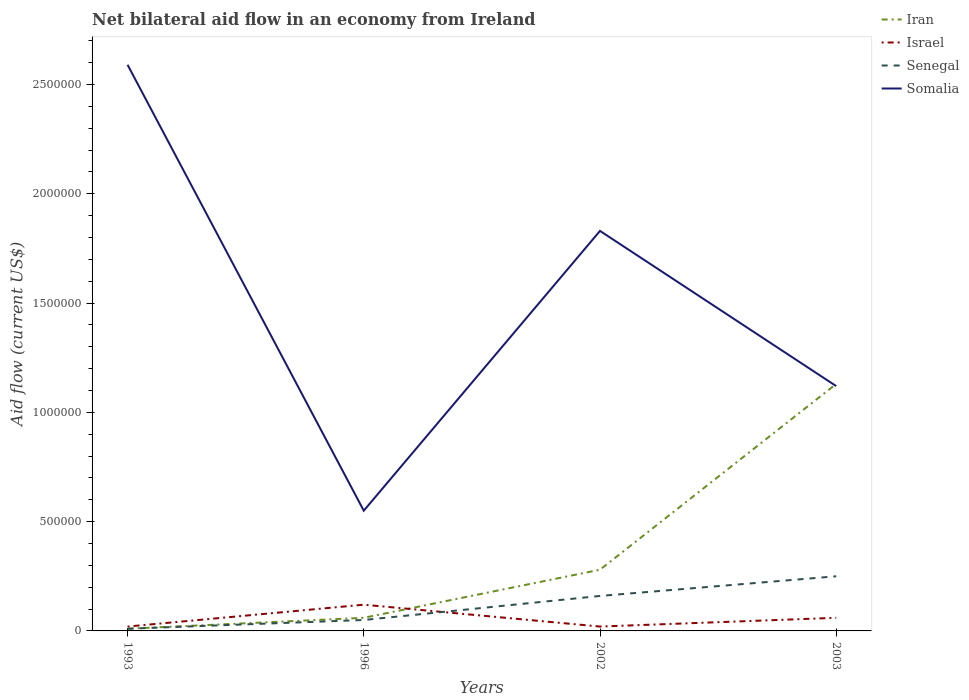In which year was the net bilateral aid flow in Somalia maximum?
Ensure brevity in your answer.  1996. What is the total net bilateral aid flow in Senegal in the graph?
Your answer should be compact. -2.00e+05. What is the difference between the highest and the second highest net bilateral aid flow in Somalia?
Give a very brief answer. 2.04e+06. Is the net bilateral aid flow in Senegal strictly greater than the net bilateral aid flow in Somalia over the years?
Ensure brevity in your answer.  Yes. How many lines are there?
Your answer should be very brief. 4. How many years are there in the graph?
Make the answer very short. 4. Does the graph contain any zero values?
Keep it short and to the point. No. Does the graph contain grids?
Ensure brevity in your answer.  No. What is the title of the graph?
Your answer should be very brief. Net bilateral aid flow in an economy from Ireland. Does "Finland" appear as one of the legend labels in the graph?
Your response must be concise. No. What is the Aid flow (current US$) in Iran in 1993?
Ensure brevity in your answer.  10000. What is the Aid flow (current US$) of Israel in 1993?
Ensure brevity in your answer.  2.00e+04. What is the Aid flow (current US$) in Senegal in 1993?
Keep it short and to the point. 10000. What is the Aid flow (current US$) in Somalia in 1993?
Your response must be concise. 2.59e+06. What is the Aid flow (current US$) in Iran in 1996?
Provide a succinct answer. 6.00e+04. What is the Aid flow (current US$) of Israel in 1996?
Provide a short and direct response. 1.20e+05. What is the Aid flow (current US$) of Israel in 2002?
Provide a succinct answer. 2.00e+04. What is the Aid flow (current US$) in Somalia in 2002?
Your answer should be very brief. 1.83e+06. What is the Aid flow (current US$) of Iran in 2003?
Ensure brevity in your answer.  1.13e+06. What is the Aid flow (current US$) of Israel in 2003?
Your answer should be compact. 6.00e+04. What is the Aid flow (current US$) in Somalia in 2003?
Ensure brevity in your answer.  1.12e+06. Across all years, what is the maximum Aid flow (current US$) of Iran?
Offer a terse response. 1.13e+06. Across all years, what is the maximum Aid flow (current US$) in Somalia?
Ensure brevity in your answer.  2.59e+06. Across all years, what is the minimum Aid flow (current US$) in Senegal?
Provide a short and direct response. 10000. What is the total Aid flow (current US$) of Iran in the graph?
Your response must be concise. 1.48e+06. What is the total Aid flow (current US$) in Israel in the graph?
Your answer should be very brief. 2.20e+05. What is the total Aid flow (current US$) in Somalia in the graph?
Make the answer very short. 6.09e+06. What is the difference between the Aid flow (current US$) of Iran in 1993 and that in 1996?
Offer a terse response. -5.00e+04. What is the difference between the Aid flow (current US$) of Israel in 1993 and that in 1996?
Give a very brief answer. -1.00e+05. What is the difference between the Aid flow (current US$) of Somalia in 1993 and that in 1996?
Make the answer very short. 2.04e+06. What is the difference between the Aid flow (current US$) in Iran in 1993 and that in 2002?
Offer a terse response. -2.70e+05. What is the difference between the Aid flow (current US$) in Israel in 1993 and that in 2002?
Keep it short and to the point. 0. What is the difference between the Aid flow (current US$) of Senegal in 1993 and that in 2002?
Offer a very short reply. -1.50e+05. What is the difference between the Aid flow (current US$) of Somalia in 1993 and that in 2002?
Give a very brief answer. 7.60e+05. What is the difference between the Aid flow (current US$) of Iran in 1993 and that in 2003?
Make the answer very short. -1.12e+06. What is the difference between the Aid flow (current US$) in Israel in 1993 and that in 2003?
Your response must be concise. -4.00e+04. What is the difference between the Aid flow (current US$) in Senegal in 1993 and that in 2003?
Offer a terse response. -2.40e+05. What is the difference between the Aid flow (current US$) in Somalia in 1993 and that in 2003?
Your response must be concise. 1.47e+06. What is the difference between the Aid flow (current US$) of Iran in 1996 and that in 2002?
Provide a succinct answer. -2.20e+05. What is the difference between the Aid flow (current US$) of Somalia in 1996 and that in 2002?
Offer a very short reply. -1.28e+06. What is the difference between the Aid flow (current US$) of Iran in 1996 and that in 2003?
Your response must be concise. -1.07e+06. What is the difference between the Aid flow (current US$) of Israel in 1996 and that in 2003?
Offer a terse response. 6.00e+04. What is the difference between the Aid flow (current US$) in Senegal in 1996 and that in 2003?
Give a very brief answer. -2.00e+05. What is the difference between the Aid flow (current US$) in Somalia in 1996 and that in 2003?
Provide a succinct answer. -5.70e+05. What is the difference between the Aid flow (current US$) in Iran in 2002 and that in 2003?
Offer a very short reply. -8.50e+05. What is the difference between the Aid flow (current US$) in Senegal in 2002 and that in 2003?
Provide a short and direct response. -9.00e+04. What is the difference between the Aid flow (current US$) of Somalia in 2002 and that in 2003?
Your answer should be very brief. 7.10e+05. What is the difference between the Aid flow (current US$) of Iran in 1993 and the Aid flow (current US$) of Somalia in 1996?
Provide a succinct answer. -5.40e+05. What is the difference between the Aid flow (current US$) of Israel in 1993 and the Aid flow (current US$) of Somalia in 1996?
Give a very brief answer. -5.30e+05. What is the difference between the Aid flow (current US$) in Senegal in 1993 and the Aid flow (current US$) in Somalia in 1996?
Give a very brief answer. -5.40e+05. What is the difference between the Aid flow (current US$) of Iran in 1993 and the Aid flow (current US$) of Israel in 2002?
Make the answer very short. -10000. What is the difference between the Aid flow (current US$) of Iran in 1993 and the Aid flow (current US$) of Senegal in 2002?
Offer a terse response. -1.50e+05. What is the difference between the Aid flow (current US$) of Iran in 1993 and the Aid flow (current US$) of Somalia in 2002?
Provide a short and direct response. -1.82e+06. What is the difference between the Aid flow (current US$) of Israel in 1993 and the Aid flow (current US$) of Somalia in 2002?
Provide a short and direct response. -1.81e+06. What is the difference between the Aid flow (current US$) of Senegal in 1993 and the Aid flow (current US$) of Somalia in 2002?
Offer a terse response. -1.82e+06. What is the difference between the Aid flow (current US$) in Iran in 1993 and the Aid flow (current US$) in Senegal in 2003?
Your answer should be very brief. -2.40e+05. What is the difference between the Aid flow (current US$) in Iran in 1993 and the Aid flow (current US$) in Somalia in 2003?
Make the answer very short. -1.11e+06. What is the difference between the Aid flow (current US$) of Israel in 1993 and the Aid flow (current US$) of Somalia in 2003?
Make the answer very short. -1.10e+06. What is the difference between the Aid flow (current US$) in Senegal in 1993 and the Aid flow (current US$) in Somalia in 2003?
Your answer should be very brief. -1.11e+06. What is the difference between the Aid flow (current US$) in Iran in 1996 and the Aid flow (current US$) in Senegal in 2002?
Your answer should be compact. -1.00e+05. What is the difference between the Aid flow (current US$) in Iran in 1996 and the Aid flow (current US$) in Somalia in 2002?
Your response must be concise. -1.77e+06. What is the difference between the Aid flow (current US$) of Israel in 1996 and the Aid flow (current US$) of Senegal in 2002?
Offer a terse response. -4.00e+04. What is the difference between the Aid flow (current US$) in Israel in 1996 and the Aid flow (current US$) in Somalia in 2002?
Provide a short and direct response. -1.71e+06. What is the difference between the Aid flow (current US$) in Senegal in 1996 and the Aid flow (current US$) in Somalia in 2002?
Give a very brief answer. -1.78e+06. What is the difference between the Aid flow (current US$) in Iran in 1996 and the Aid flow (current US$) in Somalia in 2003?
Your answer should be very brief. -1.06e+06. What is the difference between the Aid flow (current US$) of Senegal in 1996 and the Aid flow (current US$) of Somalia in 2003?
Ensure brevity in your answer.  -1.07e+06. What is the difference between the Aid flow (current US$) in Iran in 2002 and the Aid flow (current US$) in Somalia in 2003?
Provide a succinct answer. -8.40e+05. What is the difference between the Aid flow (current US$) in Israel in 2002 and the Aid flow (current US$) in Senegal in 2003?
Provide a short and direct response. -2.30e+05. What is the difference between the Aid flow (current US$) in Israel in 2002 and the Aid flow (current US$) in Somalia in 2003?
Your response must be concise. -1.10e+06. What is the difference between the Aid flow (current US$) of Senegal in 2002 and the Aid flow (current US$) of Somalia in 2003?
Your response must be concise. -9.60e+05. What is the average Aid flow (current US$) in Israel per year?
Your answer should be compact. 5.50e+04. What is the average Aid flow (current US$) in Senegal per year?
Your answer should be compact. 1.18e+05. What is the average Aid flow (current US$) of Somalia per year?
Ensure brevity in your answer.  1.52e+06. In the year 1993, what is the difference between the Aid flow (current US$) of Iran and Aid flow (current US$) of Somalia?
Make the answer very short. -2.58e+06. In the year 1993, what is the difference between the Aid flow (current US$) in Israel and Aid flow (current US$) in Senegal?
Your answer should be very brief. 10000. In the year 1993, what is the difference between the Aid flow (current US$) of Israel and Aid flow (current US$) of Somalia?
Offer a very short reply. -2.57e+06. In the year 1993, what is the difference between the Aid flow (current US$) in Senegal and Aid flow (current US$) in Somalia?
Your response must be concise. -2.58e+06. In the year 1996, what is the difference between the Aid flow (current US$) in Iran and Aid flow (current US$) in Senegal?
Provide a succinct answer. 10000. In the year 1996, what is the difference between the Aid flow (current US$) in Iran and Aid flow (current US$) in Somalia?
Your answer should be very brief. -4.90e+05. In the year 1996, what is the difference between the Aid flow (current US$) in Israel and Aid flow (current US$) in Senegal?
Provide a succinct answer. 7.00e+04. In the year 1996, what is the difference between the Aid flow (current US$) of Israel and Aid flow (current US$) of Somalia?
Provide a short and direct response. -4.30e+05. In the year 1996, what is the difference between the Aid flow (current US$) of Senegal and Aid flow (current US$) of Somalia?
Keep it short and to the point. -5.00e+05. In the year 2002, what is the difference between the Aid flow (current US$) in Iran and Aid flow (current US$) in Senegal?
Your response must be concise. 1.20e+05. In the year 2002, what is the difference between the Aid flow (current US$) of Iran and Aid flow (current US$) of Somalia?
Provide a short and direct response. -1.55e+06. In the year 2002, what is the difference between the Aid flow (current US$) of Israel and Aid flow (current US$) of Somalia?
Give a very brief answer. -1.81e+06. In the year 2002, what is the difference between the Aid flow (current US$) of Senegal and Aid flow (current US$) of Somalia?
Offer a very short reply. -1.67e+06. In the year 2003, what is the difference between the Aid flow (current US$) in Iran and Aid flow (current US$) in Israel?
Your response must be concise. 1.07e+06. In the year 2003, what is the difference between the Aid flow (current US$) in Iran and Aid flow (current US$) in Senegal?
Your response must be concise. 8.80e+05. In the year 2003, what is the difference between the Aid flow (current US$) of Iran and Aid flow (current US$) of Somalia?
Offer a terse response. 10000. In the year 2003, what is the difference between the Aid flow (current US$) in Israel and Aid flow (current US$) in Somalia?
Offer a terse response. -1.06e+06. In the year 2003, what is the difference between the Aid flow (current US$) in Senegal and Aid flow (current US$) in Somalia?
Offer a very short reply. -8.70e+05. What is the ratio of the Aid flow (current US$) of Iran in 1993 to that in 1996?
Provide a short and direct response. 0.17. What is the ratio of the Aid flow (current US$) in Israel in 1993 to that in 1996?
Give a very brief answer. 0.17. What is the ratio of the Aid flow (current US$) in Somalia in 1993 to that in 1996?
Provide a short and direct response. 4.71. What is the ratio of the Aid flow (current US$) of Iran in 1993 to that in 2002?
Provide a succinct answer. 0.04. What is the ratio of the Aid flow (current US$) in Senegal in 1993 to that in 2002?
Keep it short and to the point. 0.06. What is the ratio of the Aid flow (current US$) in Somalia in 1993 to that in 2002?
Keep it short and to the point. 1.42. What is the ratio of the Aid flow (current US$) of Iran in 1993 to that in 2003?
Offer a terse response. 0.01. What is the ratio of the Aid flow (current US$) in Israel in 1993 to that in 2003?
Make the answer very short. 0.33. What is the ratio of the Aid flow (current US$) of Somalia in 1993 to that in 2003?
Provide a succinct answer. 2.31. What is the ratio of the Aid flow (current US$) of Iran in 1996 to that in 2002?
Your answer should be compact. 0.21. What is the ratio of the Aid flow (current US$) of Senegal in 1996 to that in 2002?
Provide a succinct answer. 0.31. What is the ratio of the Aid flow (current US$) in Somalia in 1996 to that in 2002?
Provide a succinct answer. 0.3. What is the ratio of the Aid flow (current US$) of Iran in 1996 to that in 2003?
Your answer should be compact. 0.05. What is the ratio of the Aid flow (current US$) of Israel in 1996 to that in 2003?
Ensure brevity in your answer.  2. What is the ratio of the Aid flow (current US$) in Somalia in 1996 to that in 2003?
Make the answer very short. 0.49. What is the ratio of the Aid flow (current US$) of Iran in 2002 to that in 2003?
Ensure brevity in your answer.  0.25. What is the ratio of the Aid flow (current US$) of Israel in 2002 to that in 2003?
Ensure brevity in your answer.  0.33. What is the ratio of the Aid flow (current US$) of Senegal in 2002 to that in 2003?
Your answer should be compact. 0.64. What is the ratio of the Aid flow (current US$) in Somalia in 2002 to that in 2003?
Make the answer very short. 1.63. What is the difference between the highest and the second highest Aid flow (current US$) of Iran?
Offer a very short reply. 8.50e+05. What is the difference between the highest and the second highest Aid flow (current US$) of Somalia?
Give a very brief answer. 7.60e+05. What is the difference between the highest and the lowest Aid flow (current US$) of Iran?
Your response must be concise. 1.12e+06. What is the difference between the highest and the lowest Aid flow (current US$) in Israel?
Give a very brief answer. 1.00e+05. What is the difference between the highest and the lowest Aid flow (current US$) in Senegal?
Offer a very short reply. 2.40e+05. What is the difference between the highest and the lowest Aid flow (current US$) in Somalia?
Keep it short and to the point. 2.04e+06. 